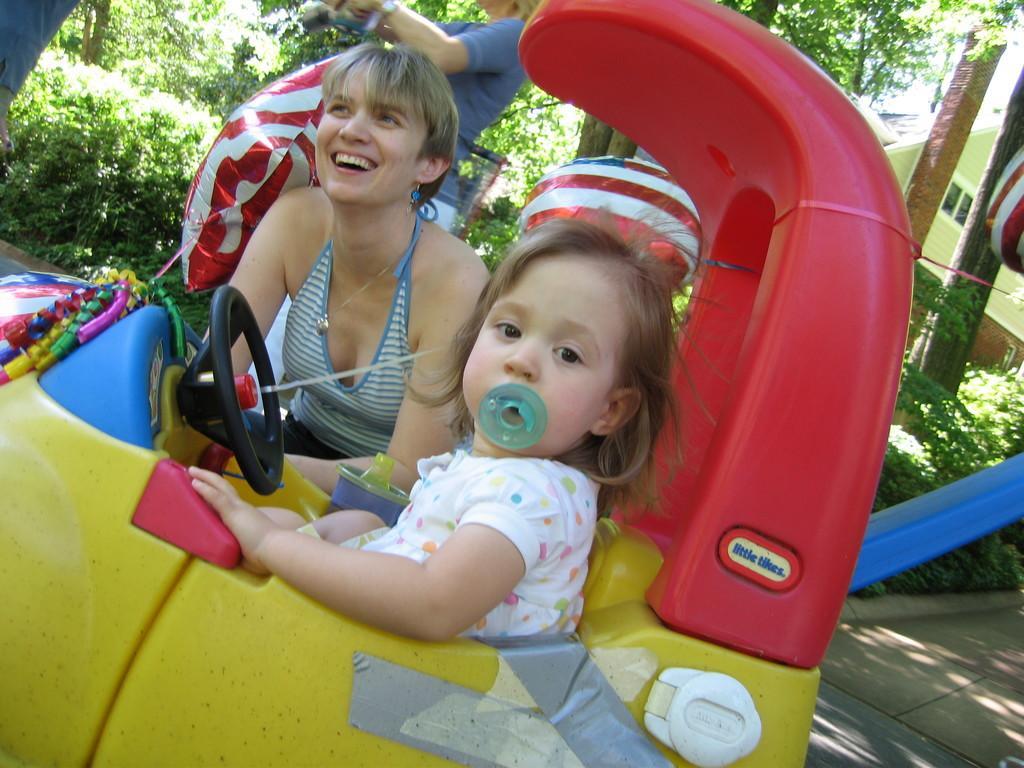In one or two sentences, can you explain what this image depicts? As we can see in the image there are trees, building, plants, few people here and there. The girl who is over here is sitting in toy car and the woman is laughing over here and there is a red and white color pillow. 